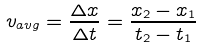<formula> <loc_0><loc_0><loc_500><loc_500>v _ { a v g } = { \frac { \Delta x } { \Delta t } } = { \frac { x _ { 2 } - x _ { 1 } } { t _ { 2 } - t _ { 1 } } }</formula> 